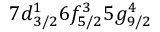<formula> <loc_0><loc_0><loc_500><loc_500>7 d _ { 3 / 2 } ^ { 1 } 6 f _ { 5 / 2 } ^ { 3 } 5 g _ { 9 / 2 } ^ { 4 }</formula> 